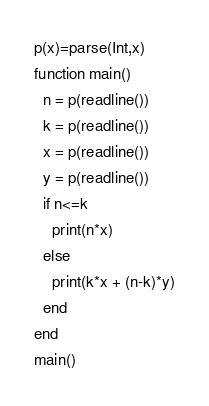<code> <loc_0><loc_0><loc_500><loc_500><_Julia_>p(x)=parse(Int,x)
function main()
  n = p(readline())
  k = p(readline())
  x = p(readline())
  y = p(readline())
  if n<=k
    print(n*x)
  else
    print(k*x + (n-k)*y)
  end
end
main()</code> 